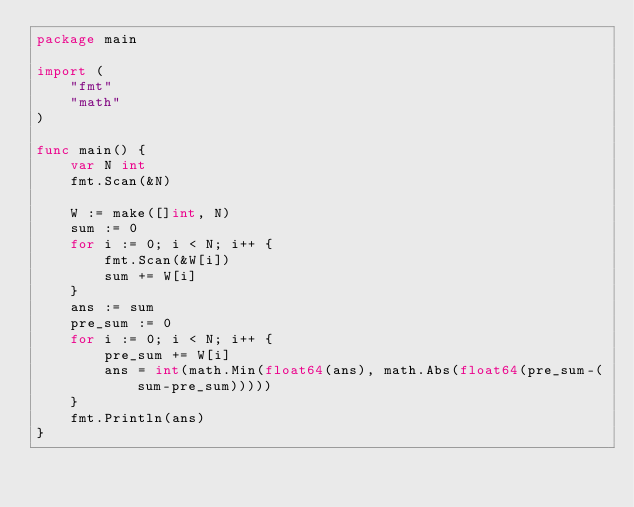Convert code to text. <code><loc_0><loc_0><loc_500><loc_500><_Go_>package main

import (
	"fmt"
	"math"
)

func main() {
	var N int
	fmt.Scan(&N)

	W := make([]int, N)
	sum := 0
	for i := 0; i < N; i++ {
		fmt.Scan(&W[i])
		sum += W[i]
	}
	ans := sum
	pre_sum := 0
	for i := 0; i < N; i++ {
		pre_sum += W[i]
		ans = int(math.Min(float64(ans), math.Abs(float64(pre_sum-(sum-pre_sum)))))
	}
	fmt.Println(ans)
}</code> 